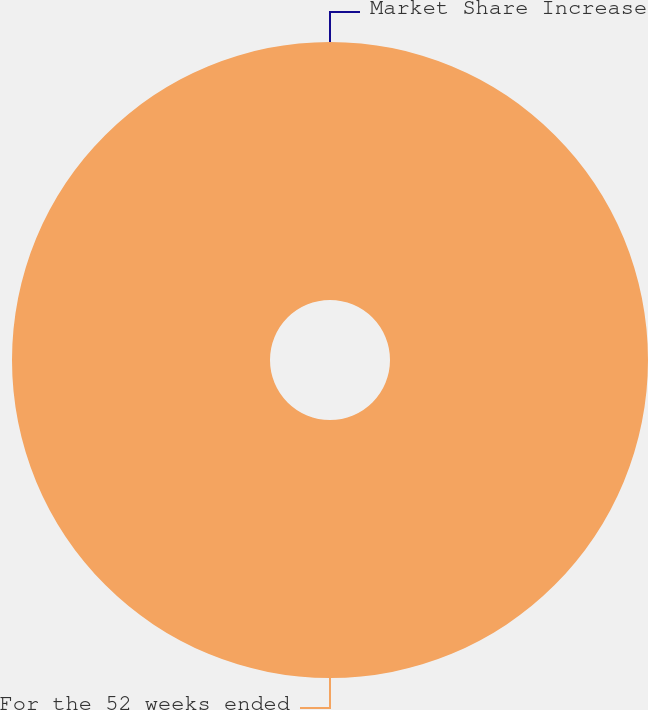Convert chart to OTSL. <chart><loc_0><loc_0><loc_500><loc_500><pie_chart><fcel>For the 52 weeks ended<fcel>Market Share Increase<nl><fcel>100.0%<fcel>0.0%<nl></chart> 